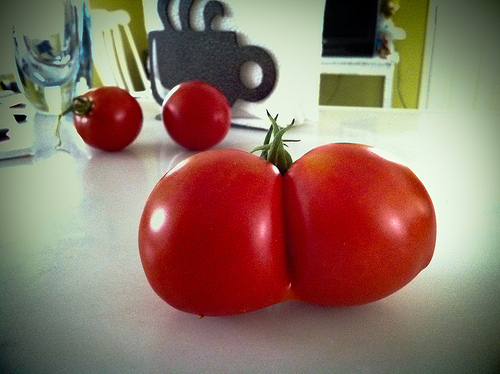<image>
Can you confirm if the wall is behind the tomato? Yes. From this viewpoint, the wall is positioned behind the tomato, with the tomato partially or fully occluding the wall. 